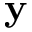Convert formula to latex. <formula><loc_0><loc_0><loc_500><loc_500>y</formula> 